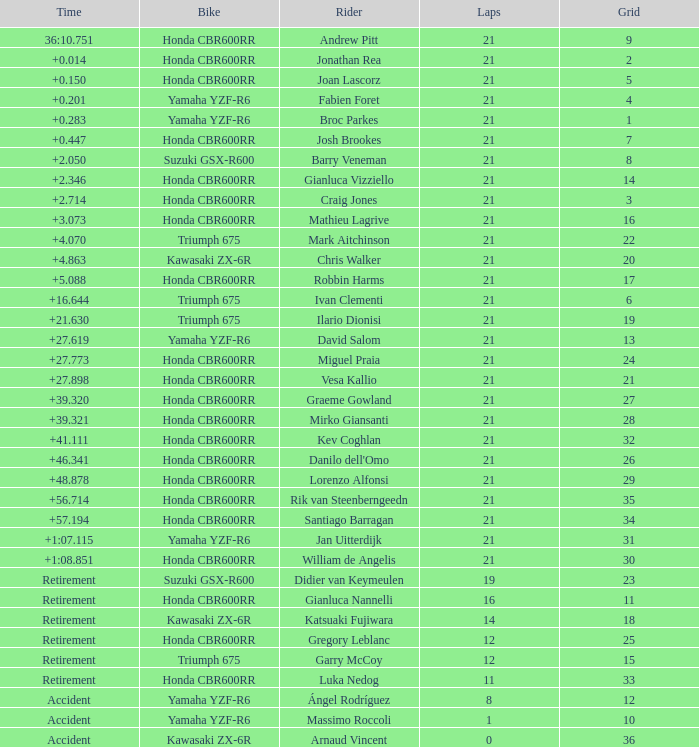What driver had the highest grid position with a time of +0.283? 1.0. 